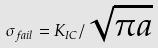Convert formula to latex. <formula><loc_0><loc_0><loc_500><loc_500>\sigma _ { f a i l } = K _ { I C } / \sqrt { \pi a }</formula> 